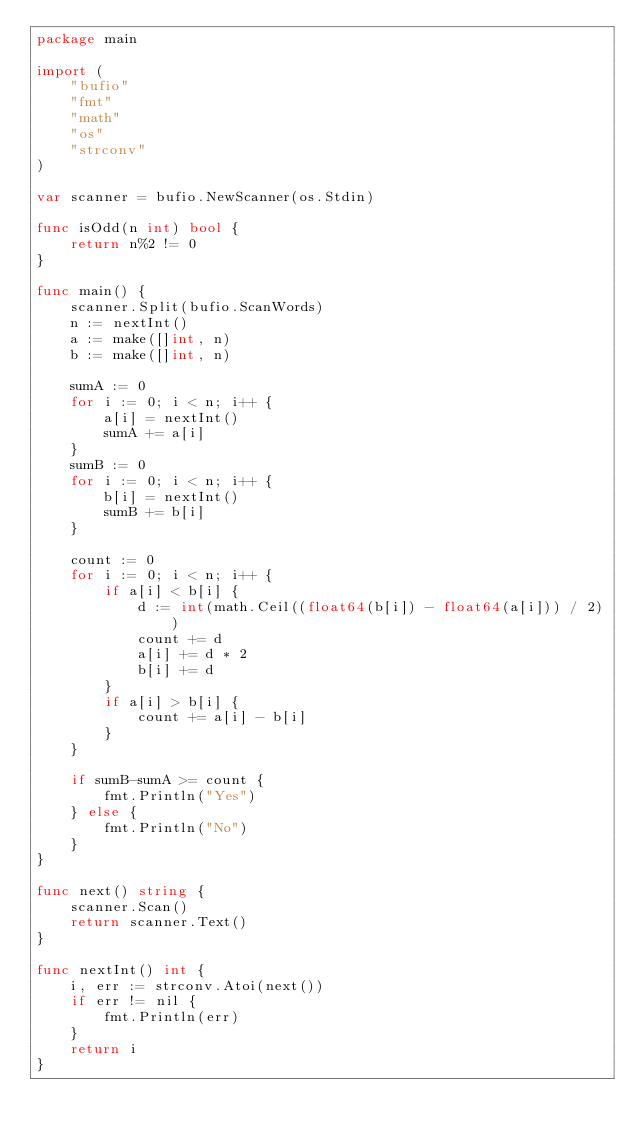<code> <loc_0><loc_0><loc_500><loc_500><_Go_>package main

import (
	"bufio"
	"fmt"
	"math"
	"os"
	"strconv"
)

var scanner = bufio.NewScanner(os.Stdin)

func isOdd(n int) bool {
	return n%2 != 0
}

func main() {
	scanner.Split(bufio.ScanWords)
	n := nextInt()
	a := make([]int, n)
	b := make([]int, n)

	sumA := 0
	for i := 0; i < n; i++ {
		a[i] = nextInt()
		sumA += a[i]
	}
	sumB := 0
	for i := 0; i < n; i++ {
		b[i] = nextInt()
		sumB += b[i]
	}

	count := 0
	for i := 0; i < n; i++ {
		if a[i] < b[i] {
			d := int(math.Ceil((float64(b[i]) - float64(a[i])) / 2))
			count += d
			a[i] += d * 2
			b[i] += d
		}
		if a[i] > b[i] {
			count += a[i] - b[i]
		}
	}

	if sumB-sumA >= count {
		fmt.Println("Yes")
	} else {
		fmt.Println("No")
	}
}

func next() string {
	scanner.Scan()
	return scanner.Text()
}

func nextInt() int {
	i, err := strconv.Atoi(next())
	if err != nil {
		fmt.Println(err)
	}
	return i
}
</code> 